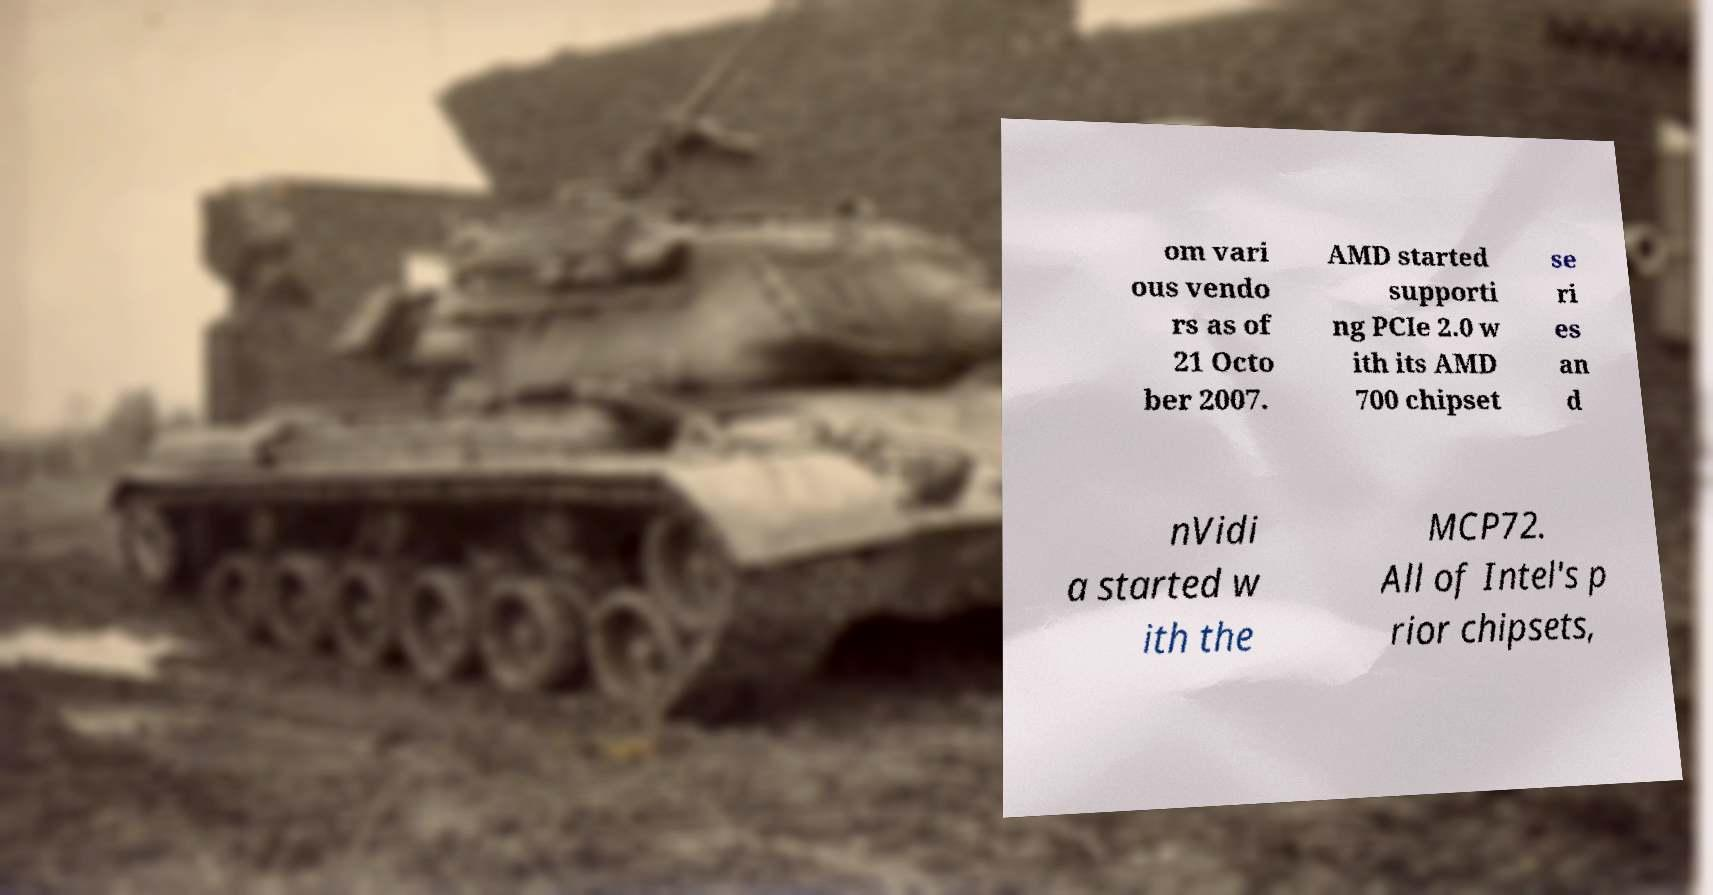There's text embedded in this image that I need extracted. Can you transcribe it verbatim? om vari ous vendo rs as of 21 Octo ber 2007. AMD started supporti ng PCIe 2.0 w ith its AMD 700 chipset se ri es an d nVidi a started w ith the MCP72. All of Intel's p rior chipsets, 